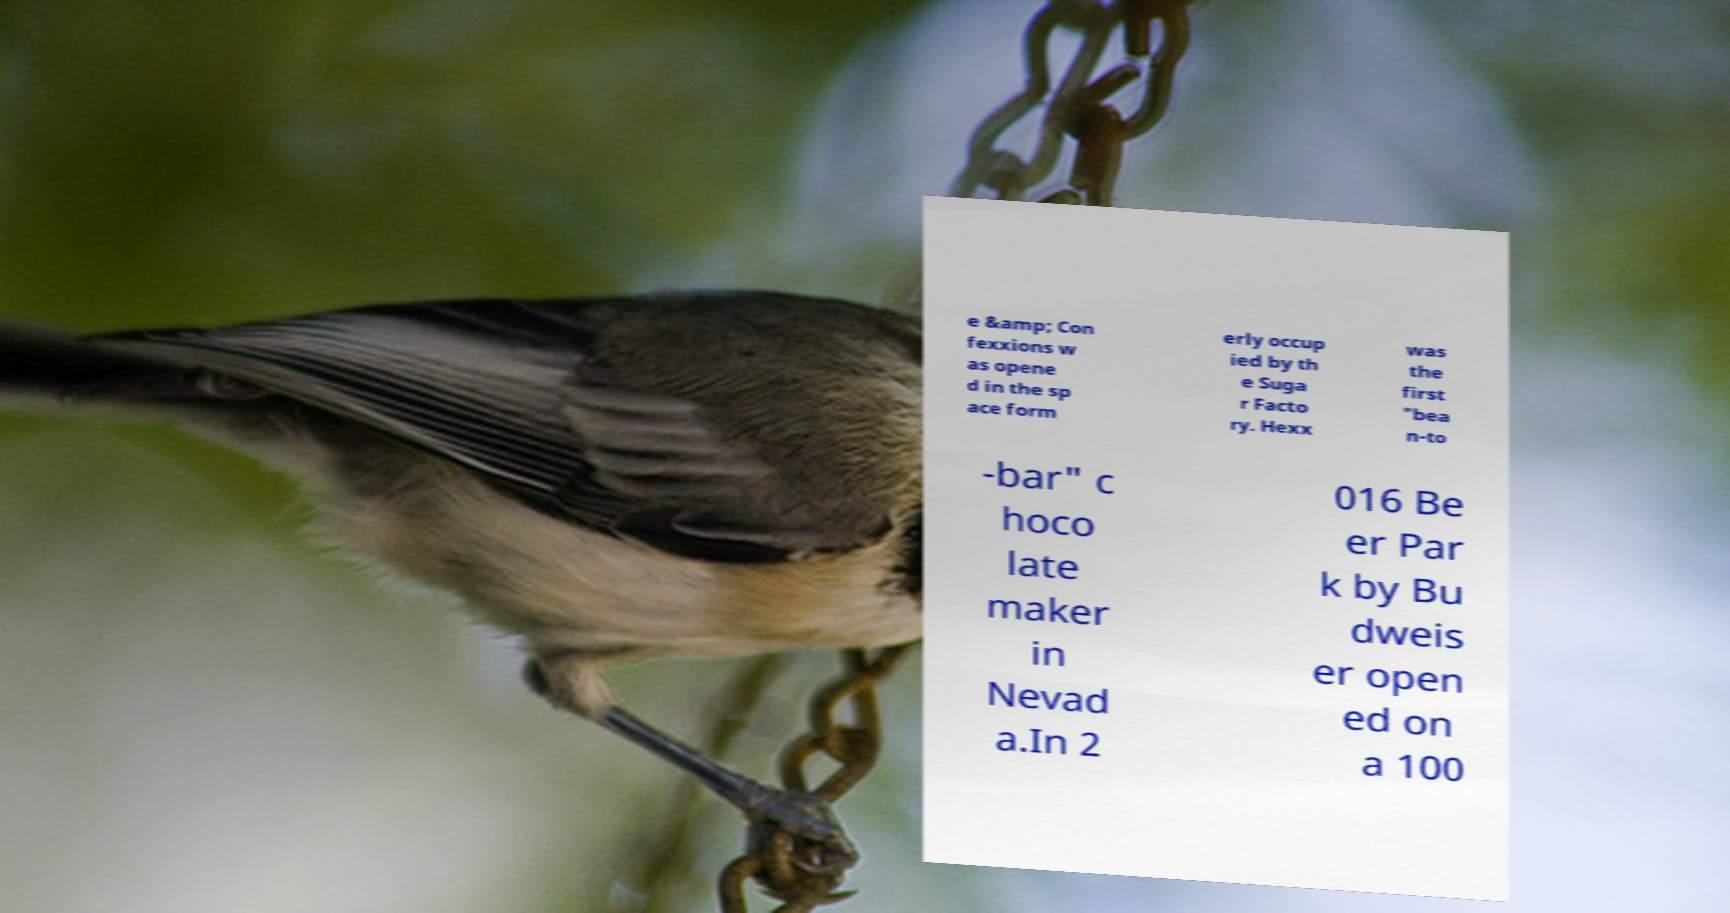I need the written content from this picture converted into text. Can you do that? e &amp; Con fexxions w as opene d in the sp ace form erly occup ied by th e Suga r Facto ry. Hexx was the first "bea n-to -bar" c hoco late maker in Nevad a.In 2 016 Be er Par k by Bu dweis er open ed on a 100 